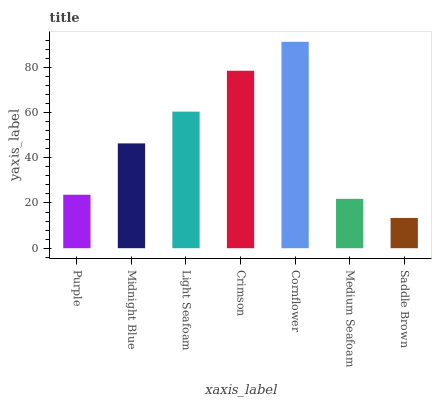Is Saddle Brown the minimum?
Answer yes or no. Yes. Is Cornflower the maximum?
Answer yes or no. Yes. Is Midnight Blue the minimum?
Answer yes or no. No. Is Midnight Blue the maximum?
Answer yes or no. No. Is Midnight Blue greater than Purple?
Answer yes or no. Yes. Is Purple less than Midnight Blue?
Answer yes or no. Yes. Is Purple greater than Midnight Blue?
Answer yes or no. No. Is Midnight Blue less than Purple?
Answer yes or no. No. Is Midnight Blue the high median?
Answer yes or no. Yes. Is Midnight Blue the low median?
Answer yes or no. Yes. Is Light Seafoam the high median?
Answer yes or no. No. Is Crimson the low median?
Answer yes or no. No. 